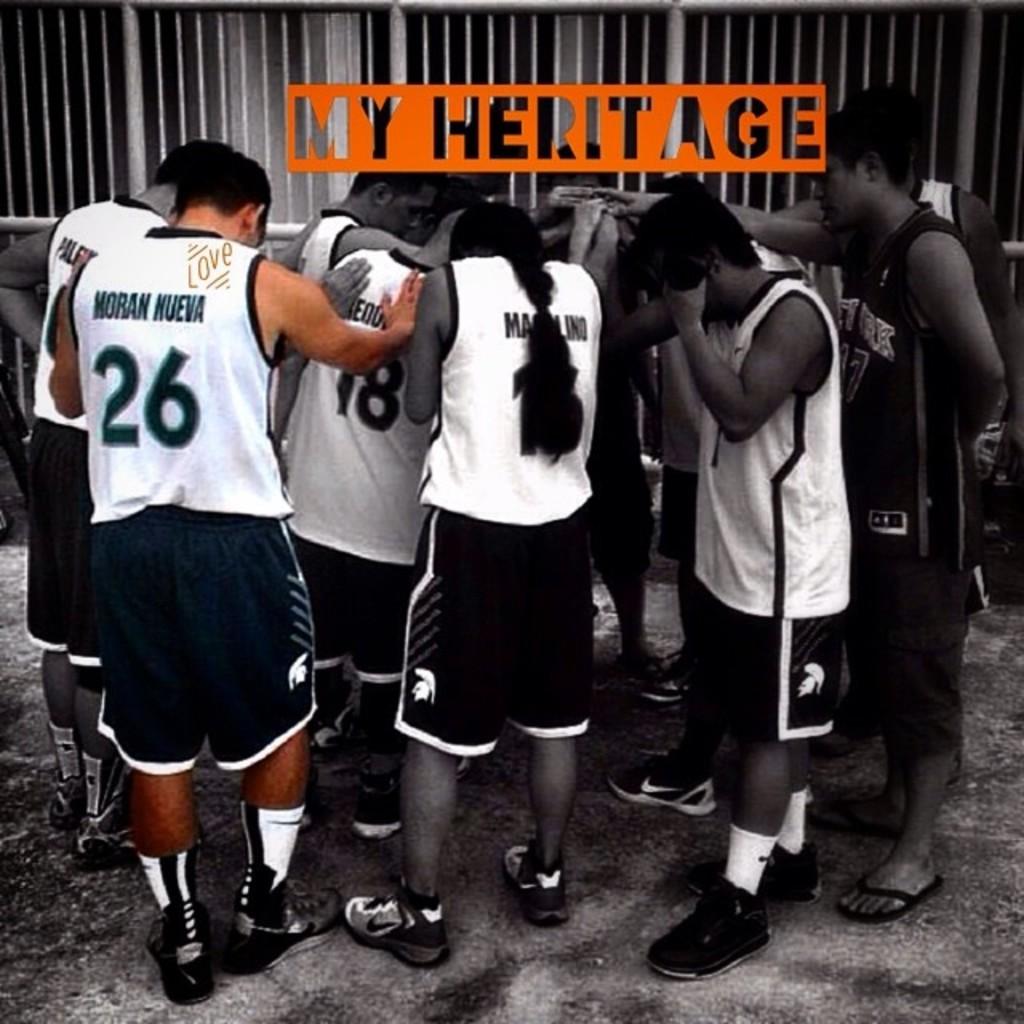What is the player's number?
Offer a terse response. 26. Whose heritage is mentioned?
Give a very brief answer. My. 